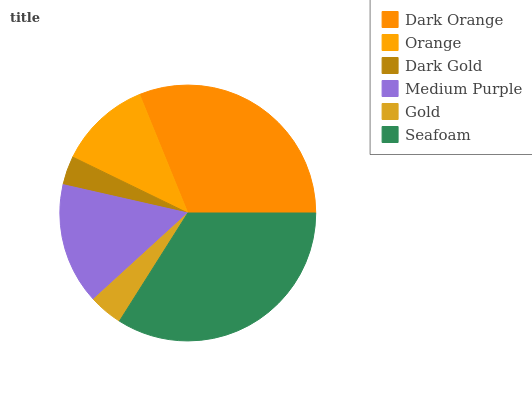Is Dark Gold the minimum?
Answer yes or no. Yes. Is Seafoam the maximum?
Answer yes or no. Yes. Is Orange the minimum?
Answer yes or no. No. Is Orange the maximum?
Answer yes or no. No. Is Dark Orange greater than Orange?
Answer yes or no. Yes. Is Orange less than Dark Orange?
Answer yes or no. Yes. Is Orange greater than Dark Orange?
Answer yes or no. No. Is Dark Orange less than Orange?
Answer yes or no. No. Is Medium Purple the high median?
Answer yes or no. Yes. Is Orange the low median?
Answer yes or no. Yes. Is Dark Gold the high median?
Answer yes or no. No. Is Dark Gold the low median?
Answer yes or no. No. 